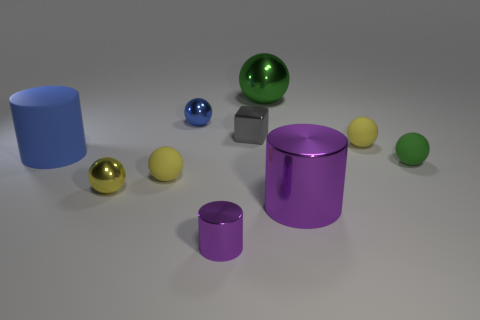Subtract all purple cylinders. How many were subtracted if there are1purple cylinders left? 1 Subtract all small yellow shiny balls. How many balls are left? 5 Subtract all blue cylinders. How many cylinders are left? 2 Subtract all blocks. How many objects are left? 9 Add 5 large gray rubber blocks. How many large gray rubber blocks exist? 5 Subtract 0 yellow cylinders. How many objects are left? 10 Subtract 5 balls. How many balls are left? 1 Subtract all yellow cylinders. Subtract all purple blocks. How many cylinders are left? 3 Subtract all cyan cylinders. How many blue balls are left? 1 Subtract all yellow balls. Subtract all metal objects. How many objects are left? 1 